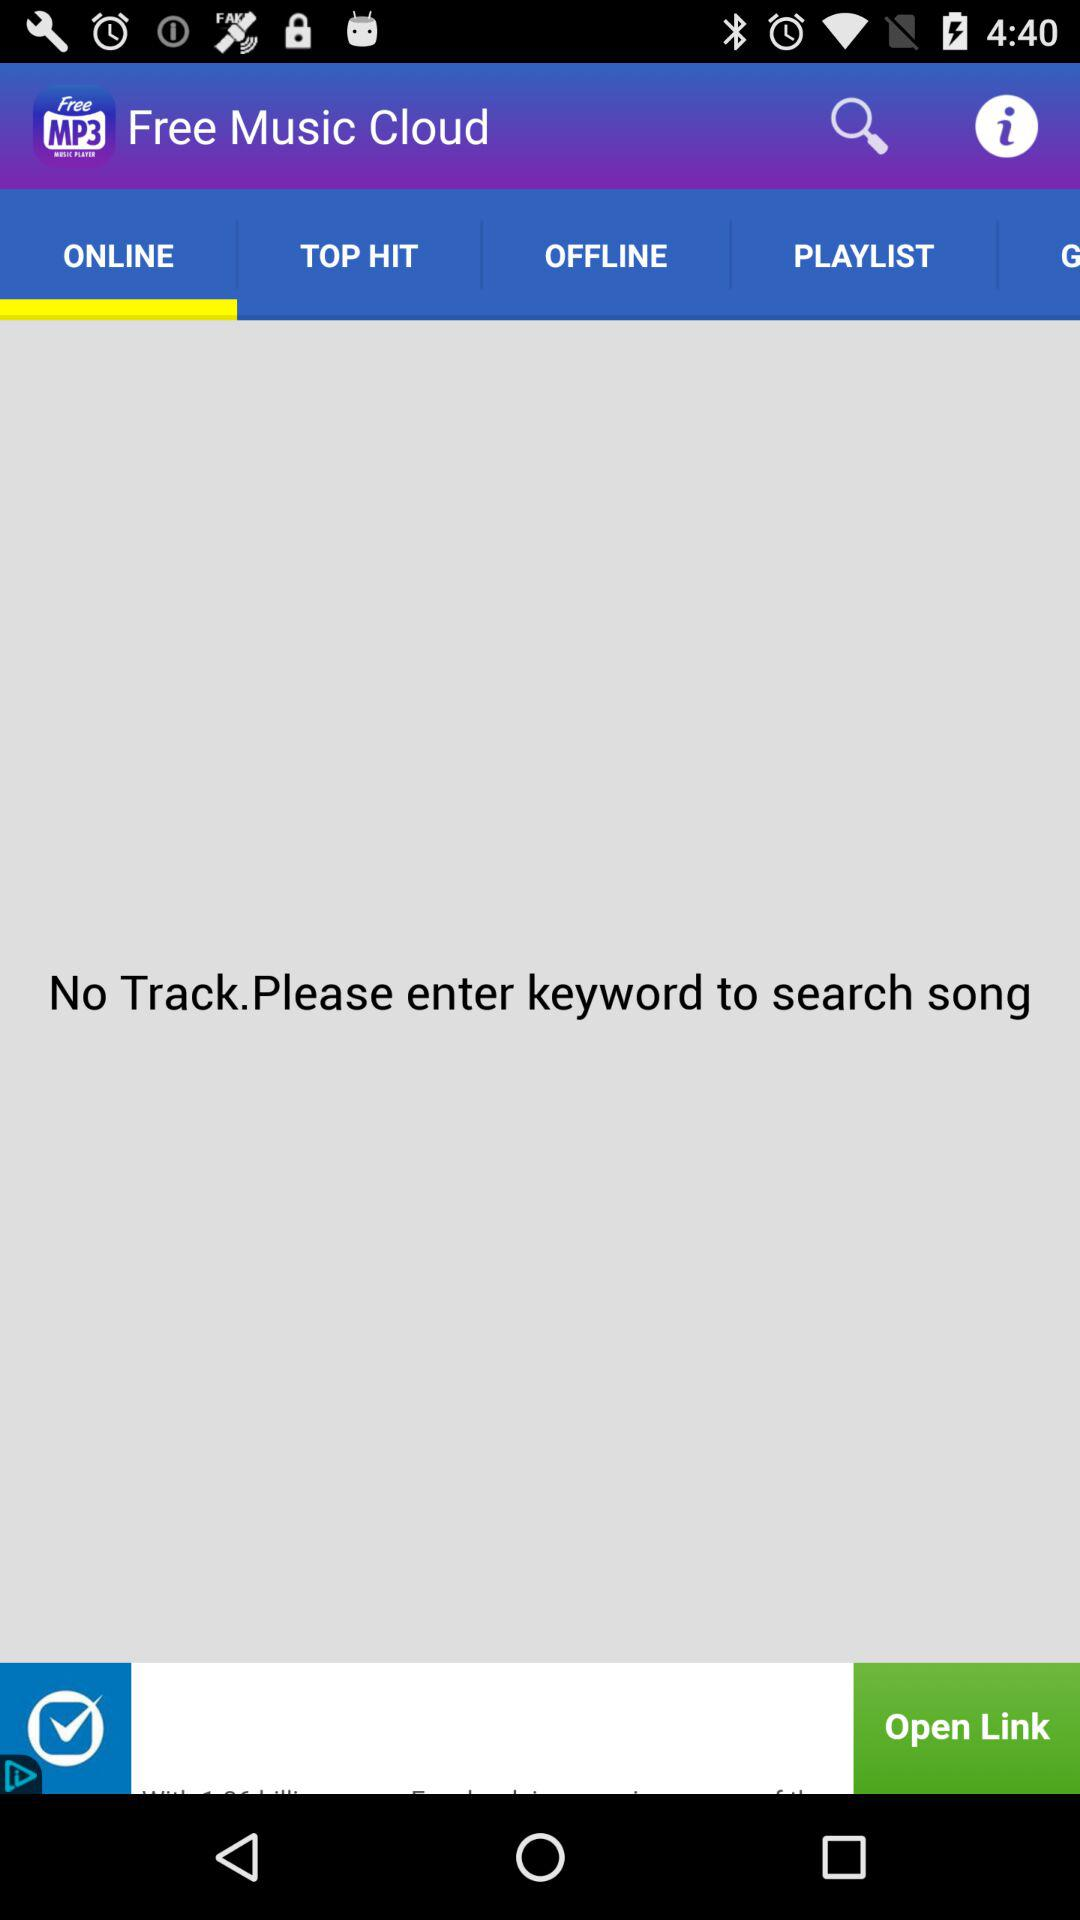Which bar is selected? The selected bar is "ONLINE". 